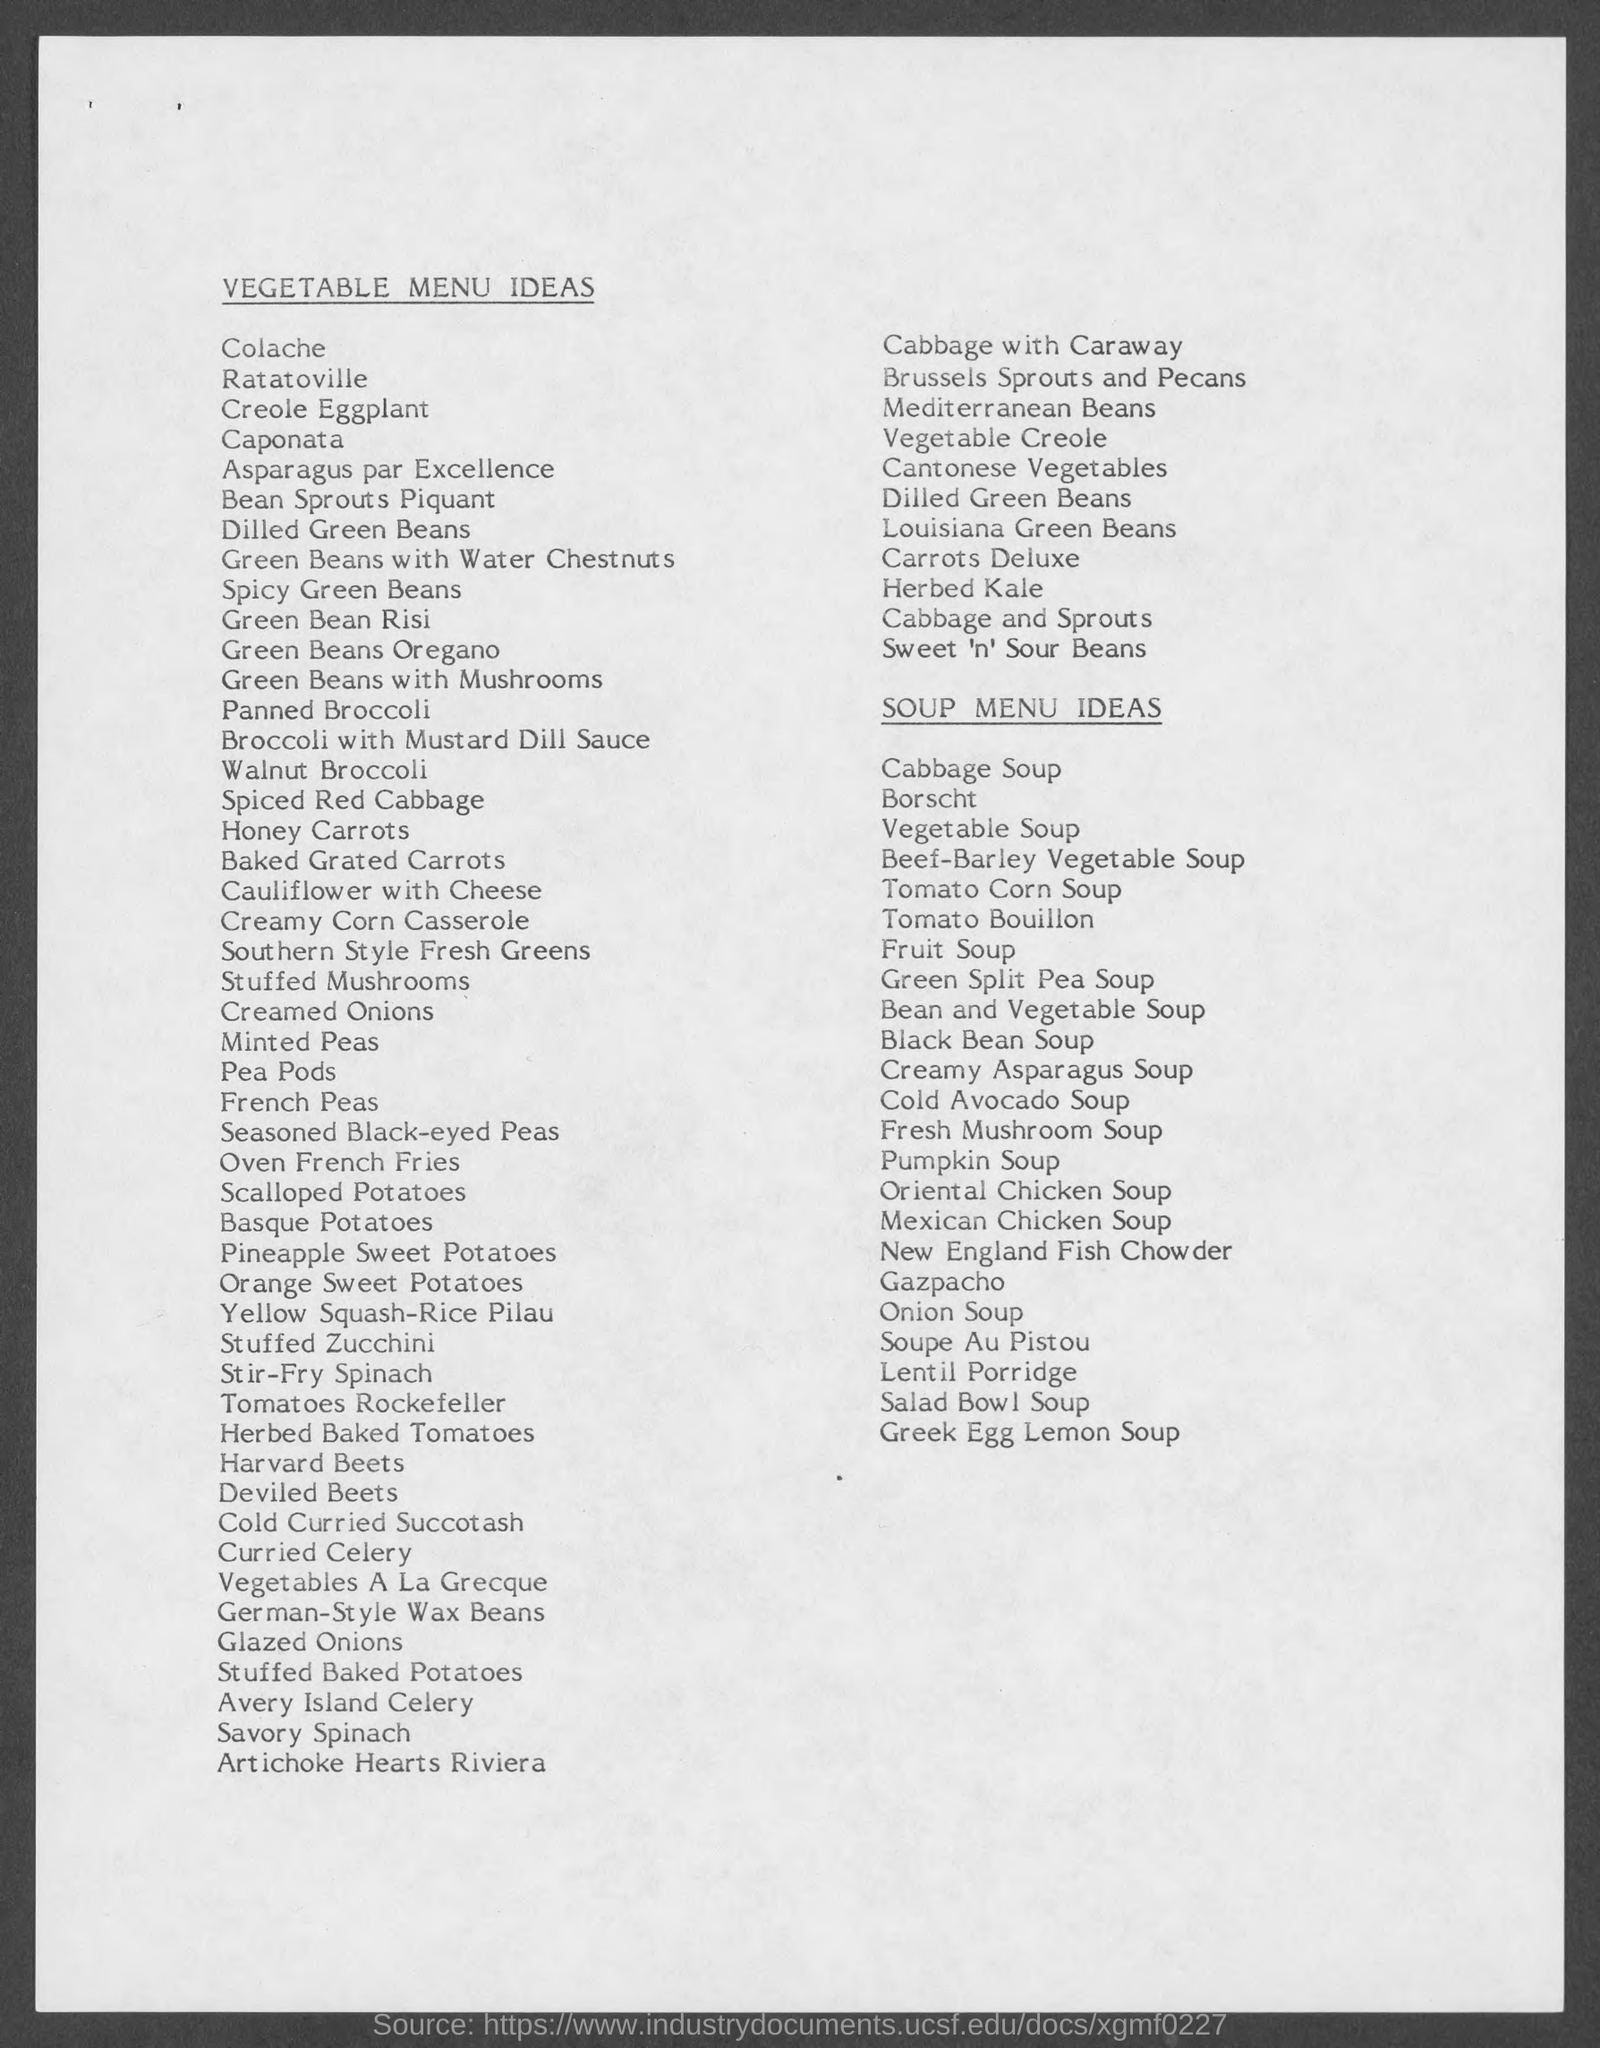What is the title of the page?
Keep it short and to the point. Vegetable Menu Ideas. 